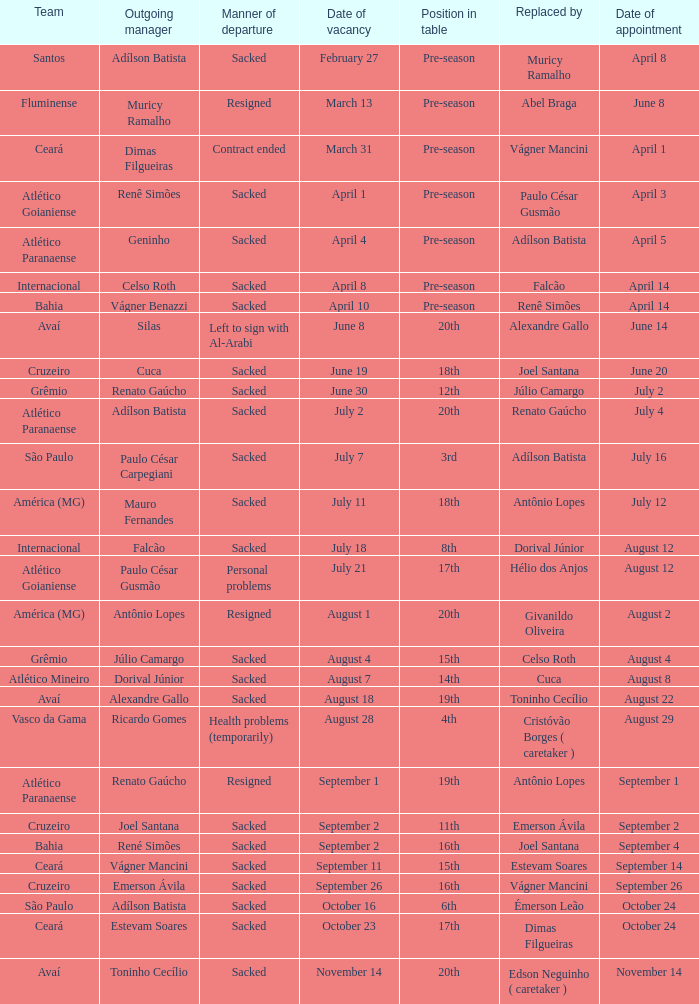On june 20, who stepped down as the manager? Cuca. 